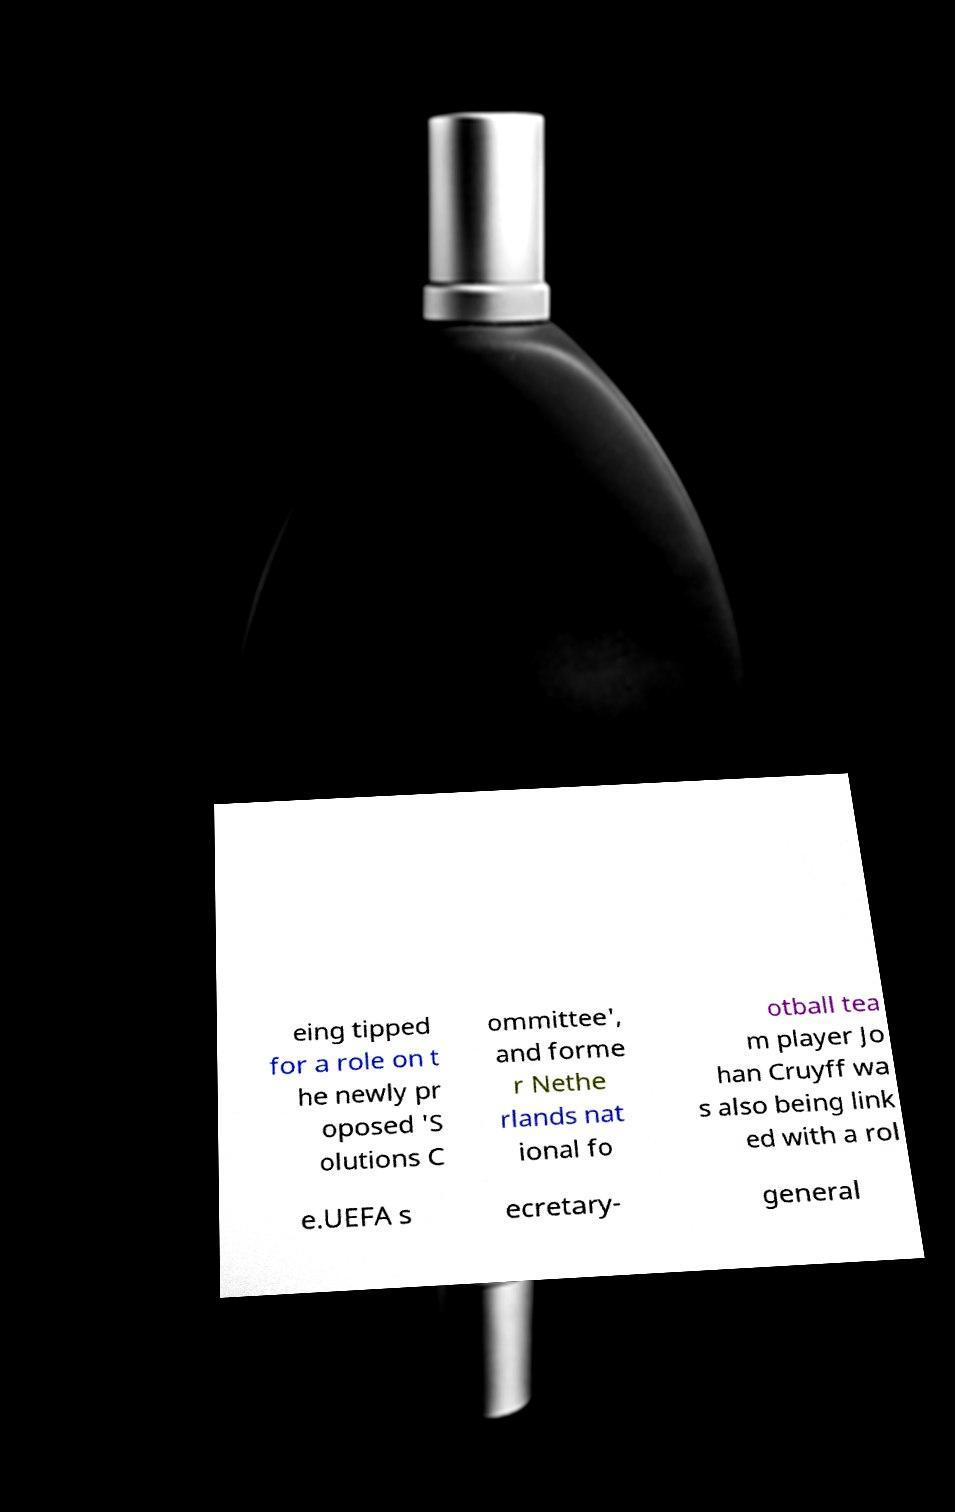For documentation purposes, I need the text within this image transcribed. Could you provide that? eing tipped for a role on t he newly pr oposed 'S olutions C ommittee', and forme r Nethe rlands nat ional fo otball tea m player Jo han Cruyff wa s also being link ed with a rol e.UEFA s ecretary- general 